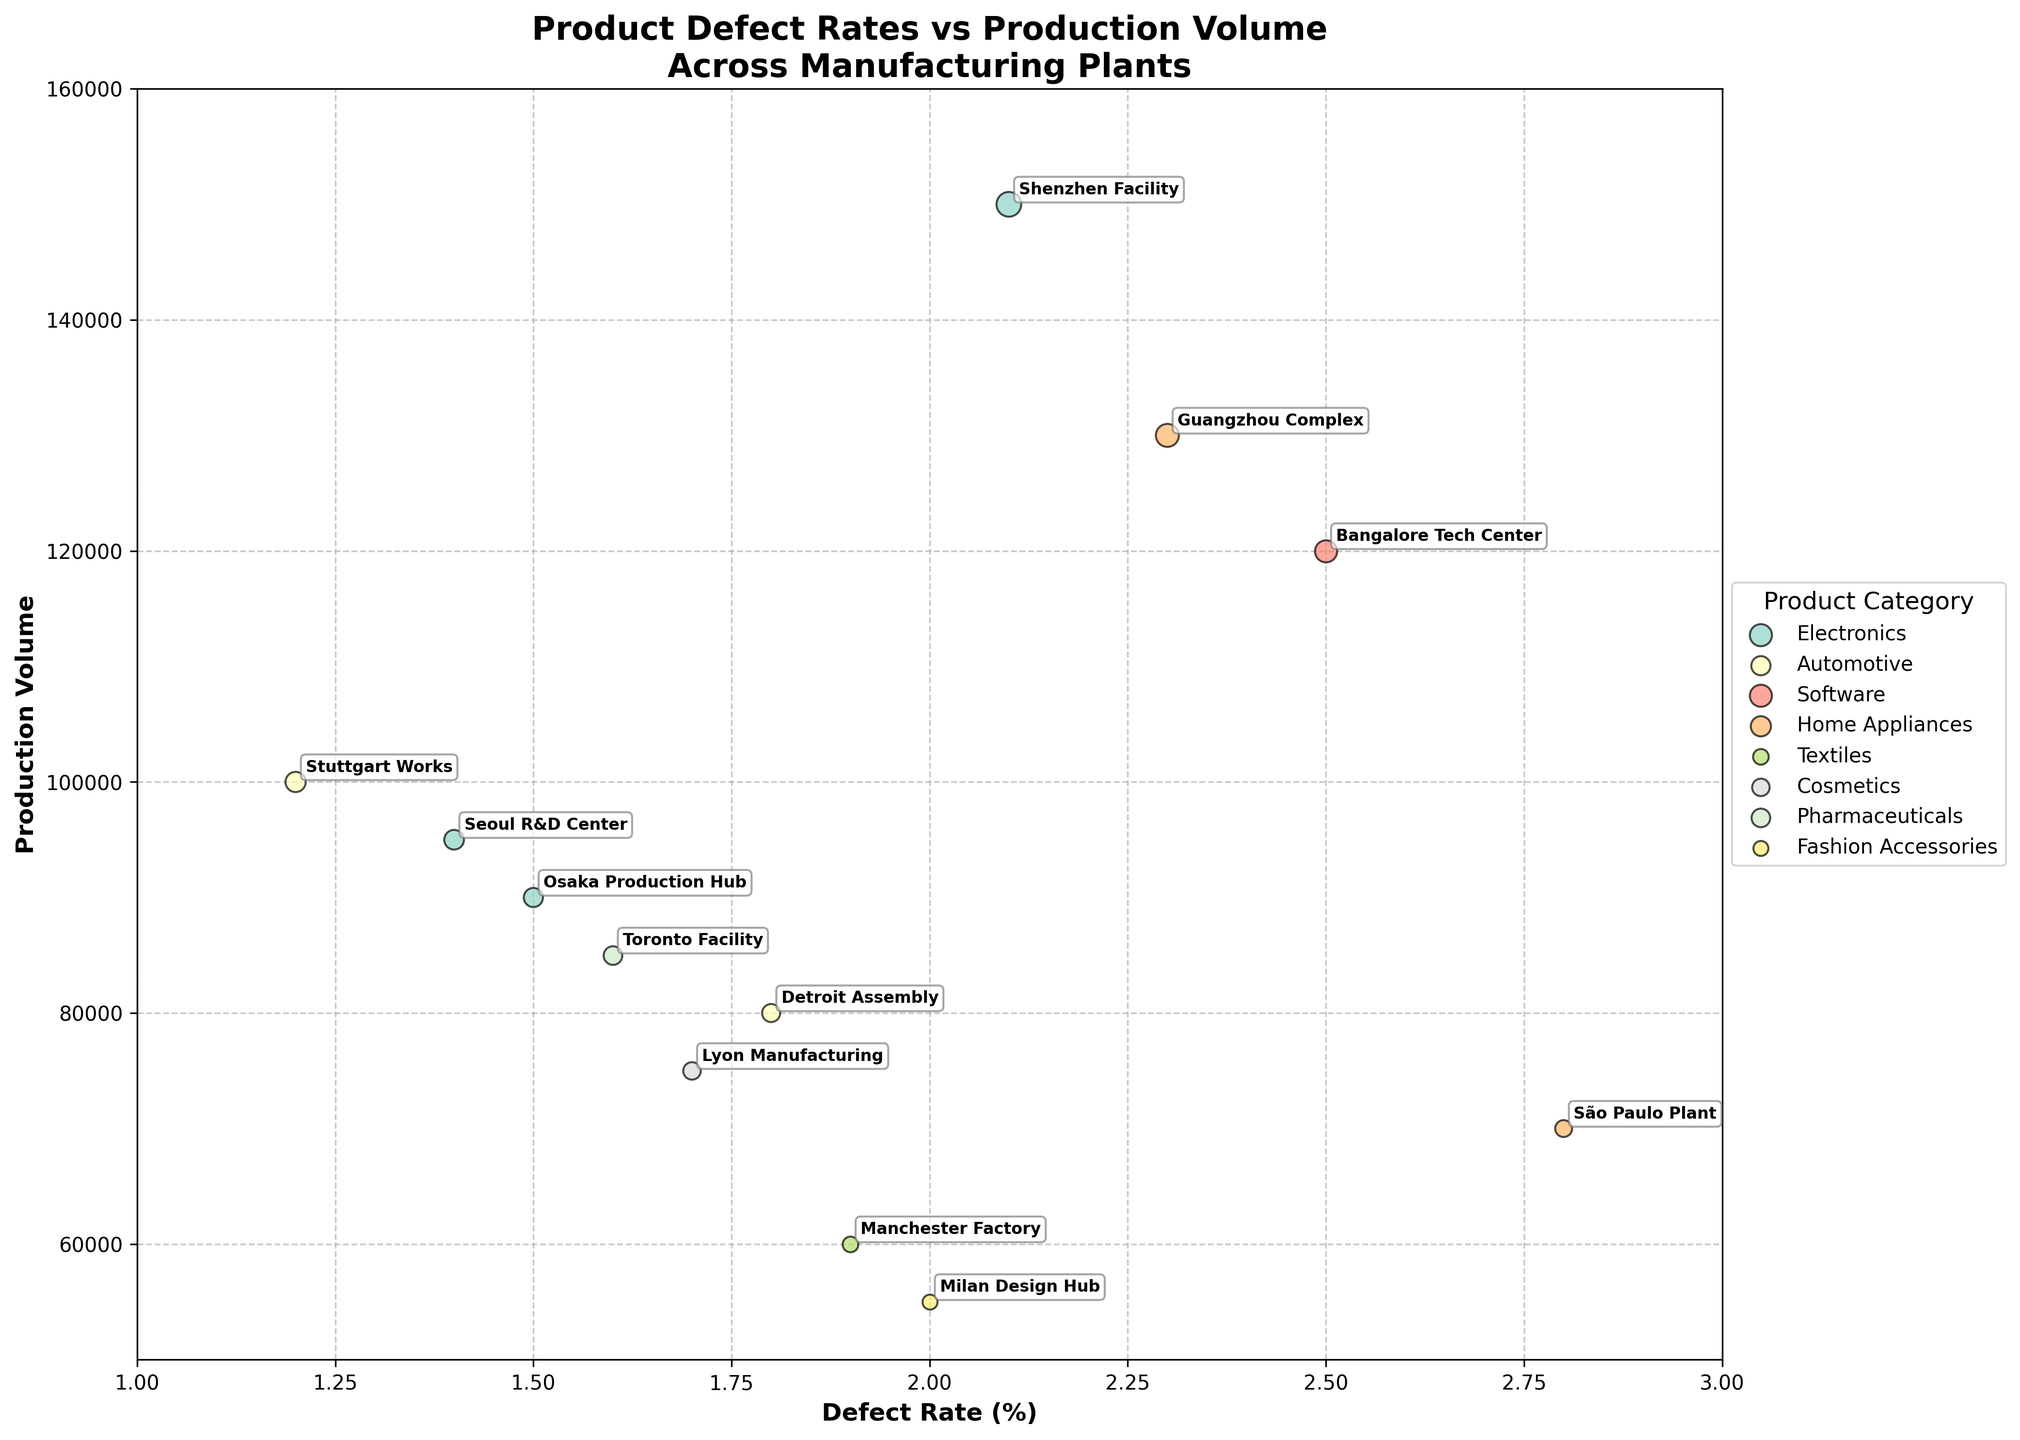What is the title of the figure? The title is displayed prominently at the top of the figure. The text present in this section provides an overview of the main content of the figure.
Answer: Product Defect Rates vs Production Volume Across Manufacturing Plants What does the x-axis represent? The x-axis label contains the information about what the x-axis represents. In this figure, this label is located horizontally at the bottom.
Answer: Defect Rate (%) What is the plant with the highest production volume? By observing the y-axis values and identifying the bubble positioned the highest on the y-axis, we can determine the plant with the highest production volume.
Answer: Shenzhen Facility Which plant has the lowest defect rate? The bubbles positioned closest to the origin on the x-axis represent plants with the lowest defect rates. Identify the one closest to the left.
Answer: Stuttgart Works Who has a higher defect rate: Detroit Assembly or Shenzhen Facility? Locate the bubbles for Detroit Assembly and Shenzhen Facility and compare their positions along the x-axis. The one further to the right has a higher defect rate.
Answer: Shenzhen Facility Which product category has the most plants on the chart? The legend groups the plants by product category, and we can count the number of plants (bubbles) corresponding to each category to find out which one has the highest count.
Answer: Electronics What is the defect rate range among all plants? The x-axis values range from the minimum to the maximum defect rates. The lowest and highest x-axis values give us this range.
Answer: 1.2% to 2.8% Compare the defect rates of plants in China. What do you observe? Locate Guangzhou Complex and Shenzhen Facility, note their positions on the x-axis and compare them directly.
Answer: Guangzhou Complex: 2.3%, Shenzhen Facility: 2.1% What is the total production volume of the plants from the USA and Germany combined? Add the y-axis values (production volumes) for Detroit Assembly and Stuttgart Works. Detroit Assembly (80,000) + Stuttgart Works (100,000) = 180,000
Answer: 180,000 How many product categories are represented on the chart? The legend lists all unique product categories plotted. Count these categories to determine the total number.
Answer: 8 